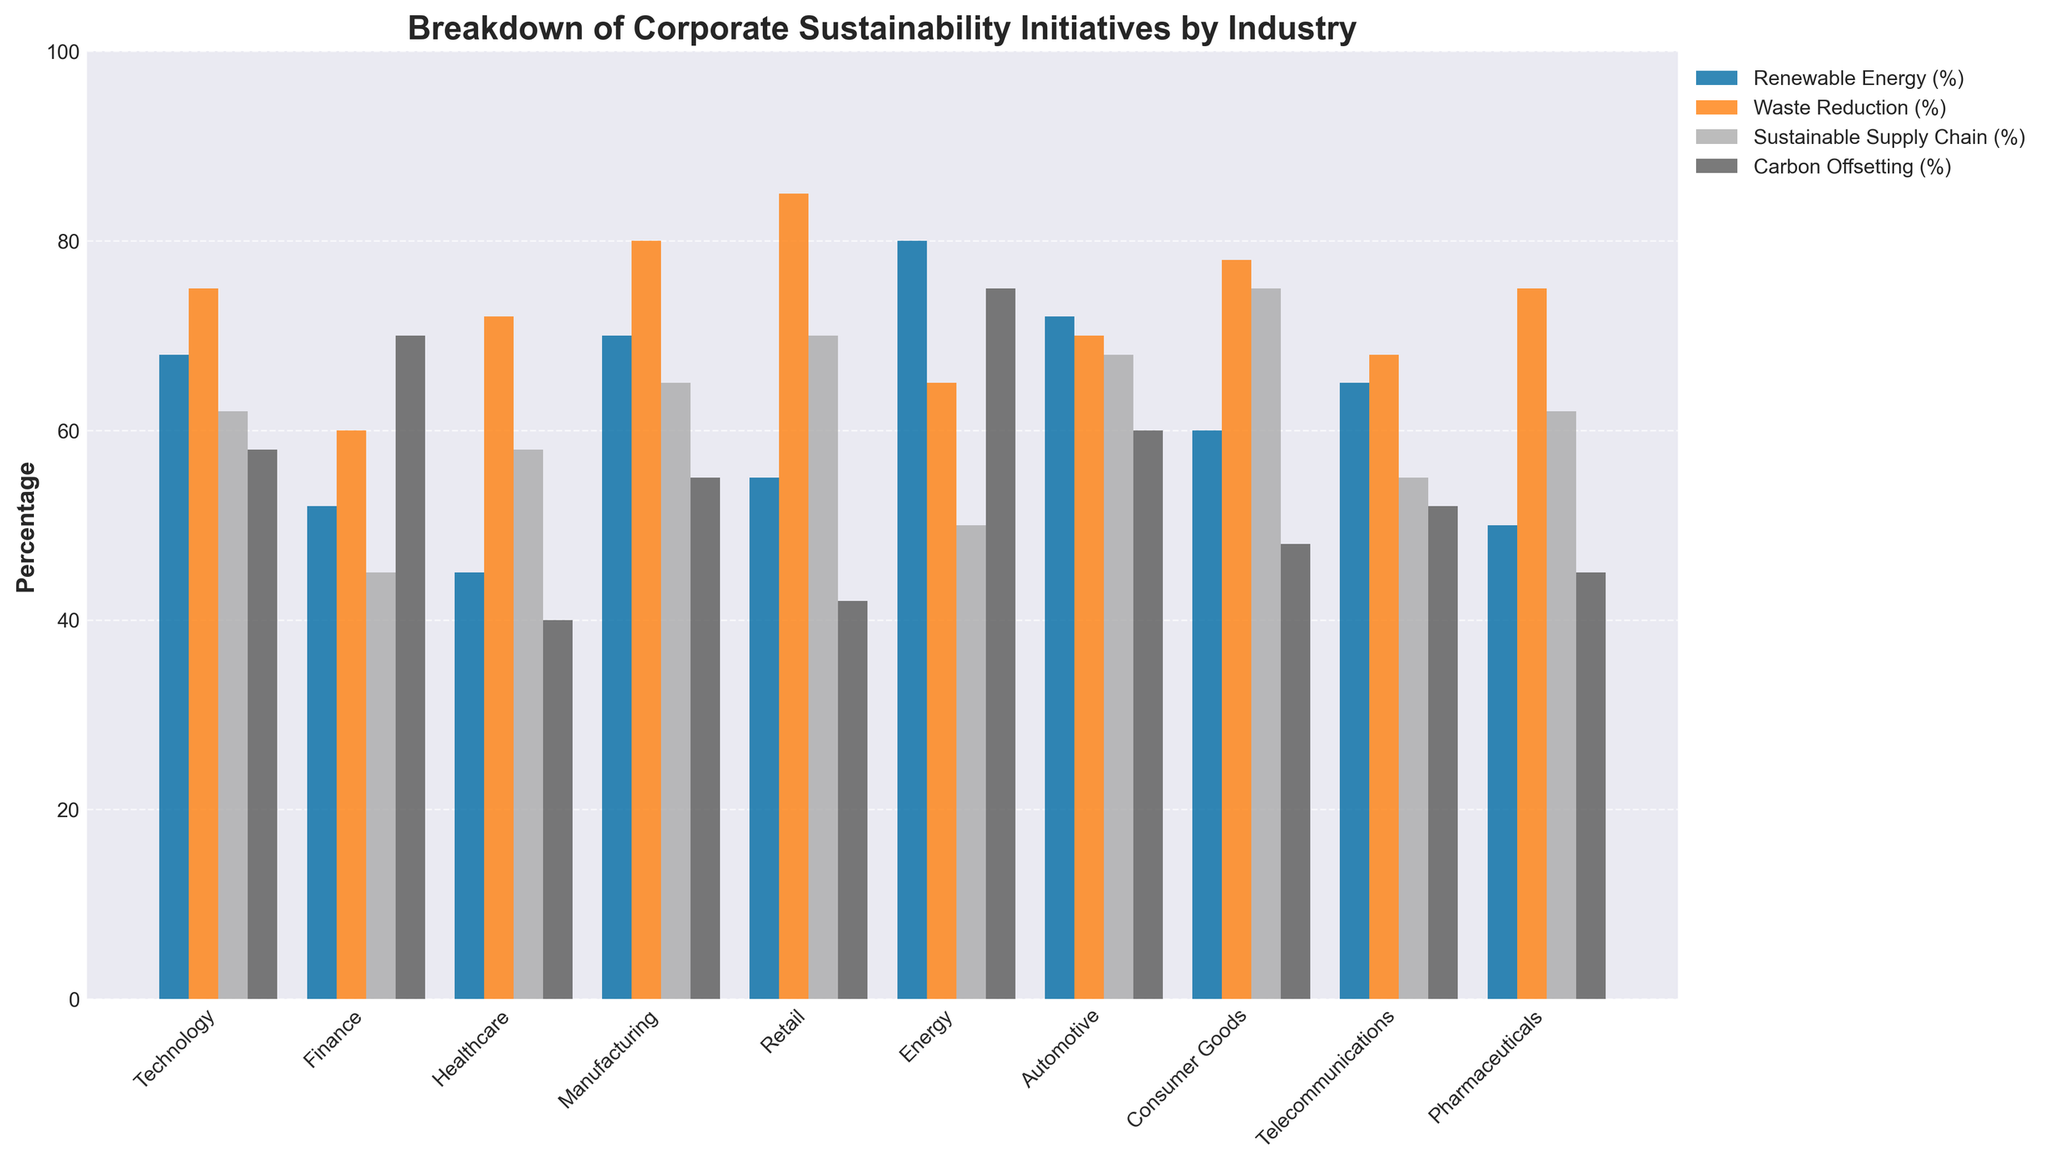What is the percentage difference in waste reduction initiatives between the retail and pharmaceutical industries? Retail has 85% in waste reduction while Pharmaceuticals has 75%. The difference is 85% - 75% = 10%.
Answer: 10% Which industry has the highest percentage of renewable energy initiatives? By observing the bar heights, the Energy industry has the highest percentage of renewable energy initiatives at 80%.
Answer: Energy Between the Healthcare and Finance industries, which one has a higher emphasis on sustainable supply chain initiatives? Healthcare has 58% in sustainable supply chain, while Finance has 45%. Thus, Healthcare has a higher emphasis.
Answer: Healthcare What is the average percentage of carbon offsetting initiatives for the Technology and Automotive industries? Technology has 58% and Automotive has 60% in carbon offsetting. The average is (58% + 60%) / 2 = 59%.
Answer: 59% Which industry has the lowest percentage of sustainable supply chain initiatives? By visually comparing the bar heights for sustainable supply chain, Finance has the lowest percentage at 45%.
Answer: Finance How many industries have renewable energy initiatives above 60%? Industries with renewable energy above 60% are Technology (68%), Manufacturing (70%), Energy (80%), Automotive (72%), and Telecommunications (65%). There are 5 such industries.
Answer: 5 Compare the carbon offsetting initiatives between the Telecommunications and Healthcare industries. Which one is higher? Telecommunications has 52% in carbon offsetting while Healthcare has 40%. Hence, Telecommunications is higher.
Answer: Telecommunications What is the percentage gap between the highest and lowest industries in waste reduction initiatives? The highest in waste reduction is Retail (85%) and the lowest is Energy (65%). The gap is 85% - 65% = 20%.
Answer: 20% What is the average percentage of renewable energy initiatives across all industries? Summing up all renewable energy percentages: (68 + 52 + 45 + 70 + 55 + 80 + 72 + 60 + 65 + 50) = 617. The average is 617 / 10 = 61.7%.
Answer: 61.7% Which industry has identical percentages in two different sustainability initiative categories? The Technology industry has 62% both in renewable energy and sustainable supply chain initiatives.
Answer: Technology 